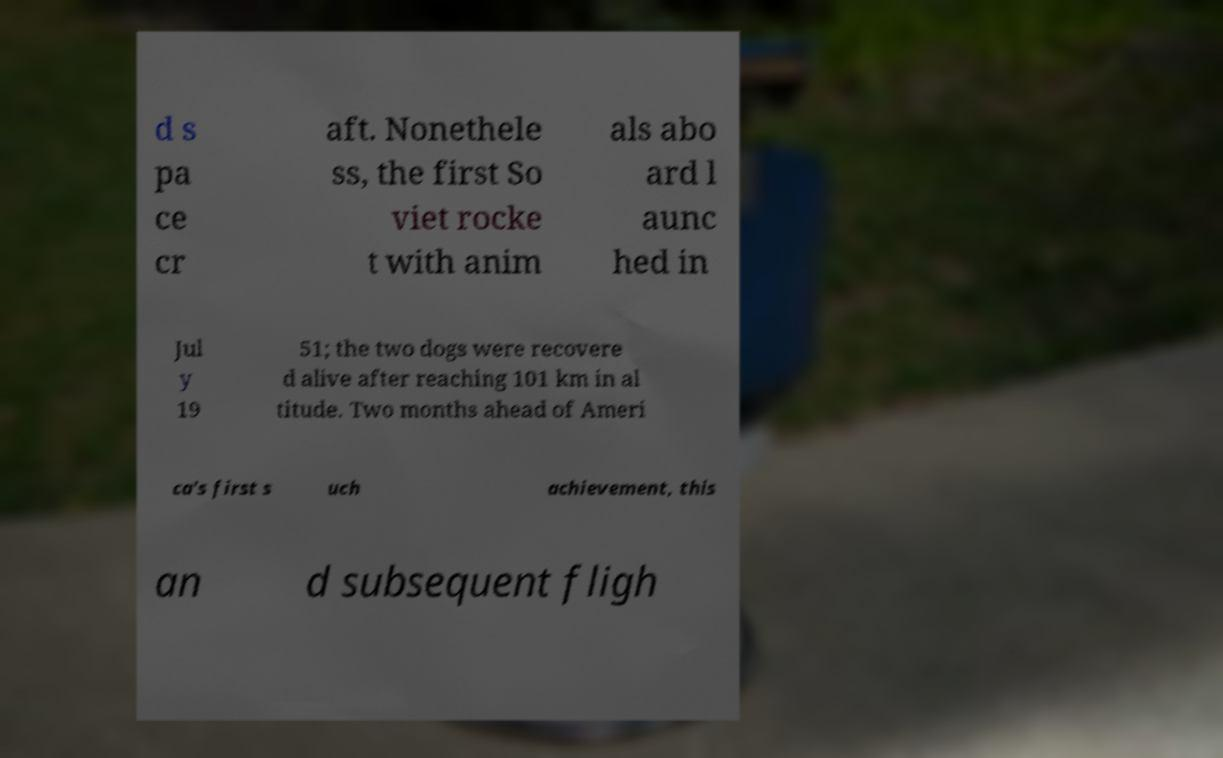There's text embedded in this image that I need extracted. Can you transcribe it verbatim? d s pa ce cr aft. Nonethele ss, the first So viet rocke t with anim als abo ard l aunc hed in Jul y 19 51; the two dogs were recovere d alive after reaching 101 km in al titude. Two months ahead of Ameri ca's first s uch achievement, this an d subsequent fligh 